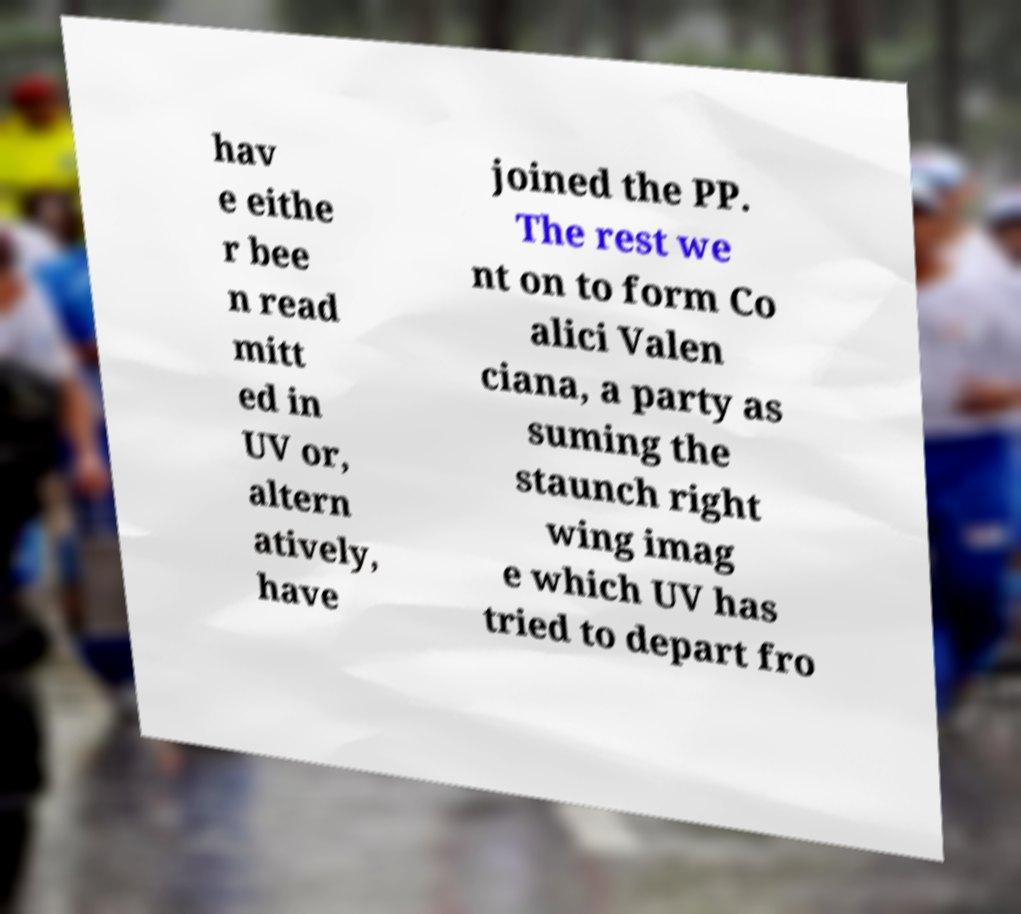Could you assist in decoding the text presented in this image and type it out clearly? hav e eithe r bee n read mitt ed in UV or, altern atively, have joined the PP. The rest we nt on to form Co alici Valen ciana, a party as suming the staunch right wing imag e which UV has tried to depart fro 